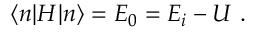<formula> <loc_0><loc_0><loc_500><loc_500>\langle n | H | n \rangle = E _ { 0 } = E _ { i } - U \ .</formula> 